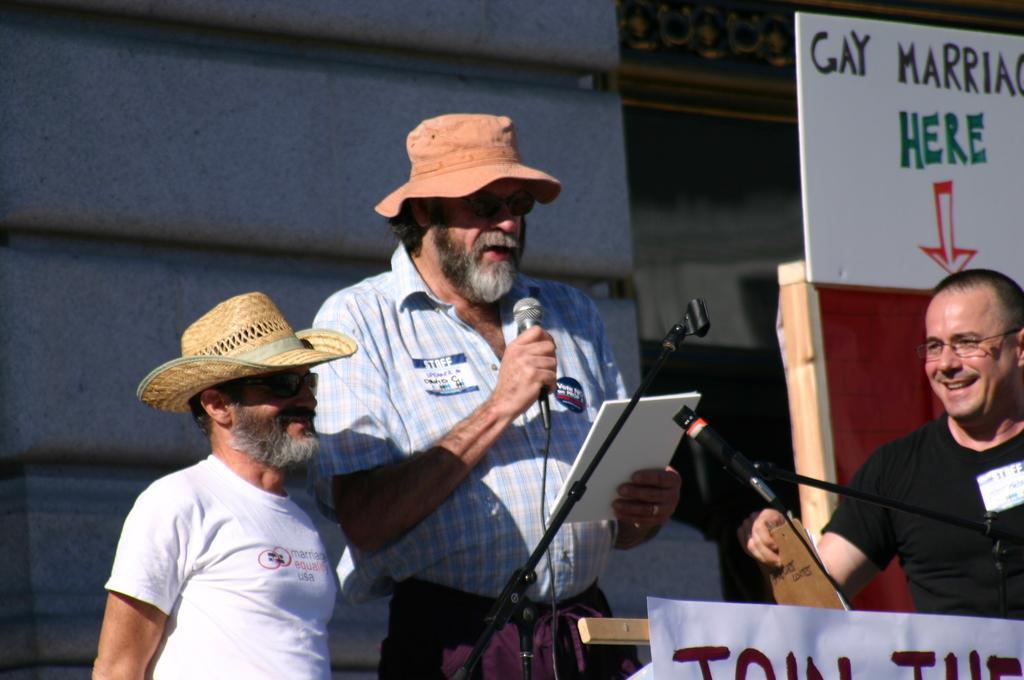Could you give a brief overview of what you see in this image? In the center of the image we can see person standing at the mic holding a book. On the right of the image there is a board and person standing with book. In the background there is a building. 